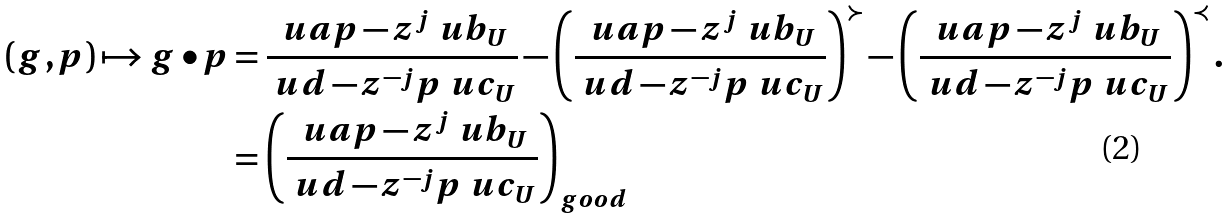Convert formula to latex. <formula><loc_0><loc_0><loc_500><loc_500>( g , p ) \mapsto g \bullet p & = \frac { \ u a p - z ^ { j } \ u b _ { U } } { \ u d - z ^ { - j } p \ u c _ { U } } - \left ( \frac { \ u a p - z ^ { j } \ u b _ { U } } { \ u d - z ^ { - j } p \ u c _ { U } } \right ) ^ { \succ } - \left ( \frac { \ u a p - z ^ { j } \ u b _ { U } } { \ u d - z ^ { - j } p \ u c _ { U } } \right ) ^ { \prec } . \\ & = \left ( \frac { \ u a p - z ^ { j } \ u b _ { U } } { \ u d - z ^ { - j } p \ u c _ { U } } \right ) _ { g o o d }</formula> 